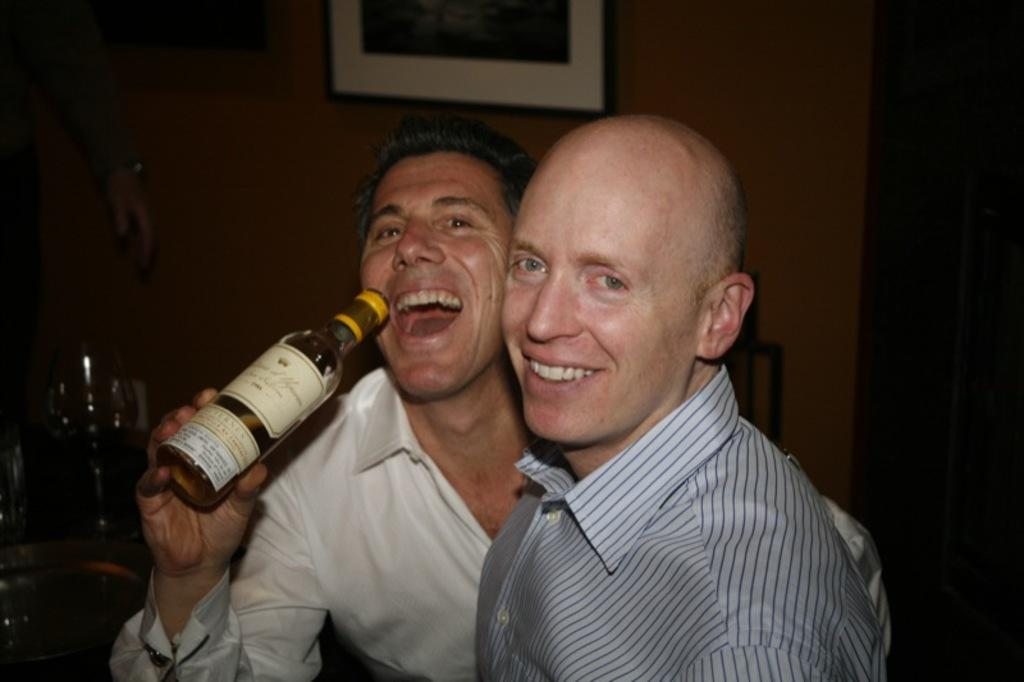How many people are in the image? There are two persons in the image. What is the facial expression of the persons in the image? Both persons are smiling. What is one of the persons holding in his hand? One of the persons is holding a bottle in his hand. What can be seen in the background of the image? There is a wine glass and a wall in the background of the image. What is attached to the wall in the background of the image? There is a photo frame attached to the wall in the background of the image. Is there any quicksand visible in the image? No, there is no quicksand present in the image. What type of plant can be seen growing near the persons in the image? There is no plant visible in the image. 